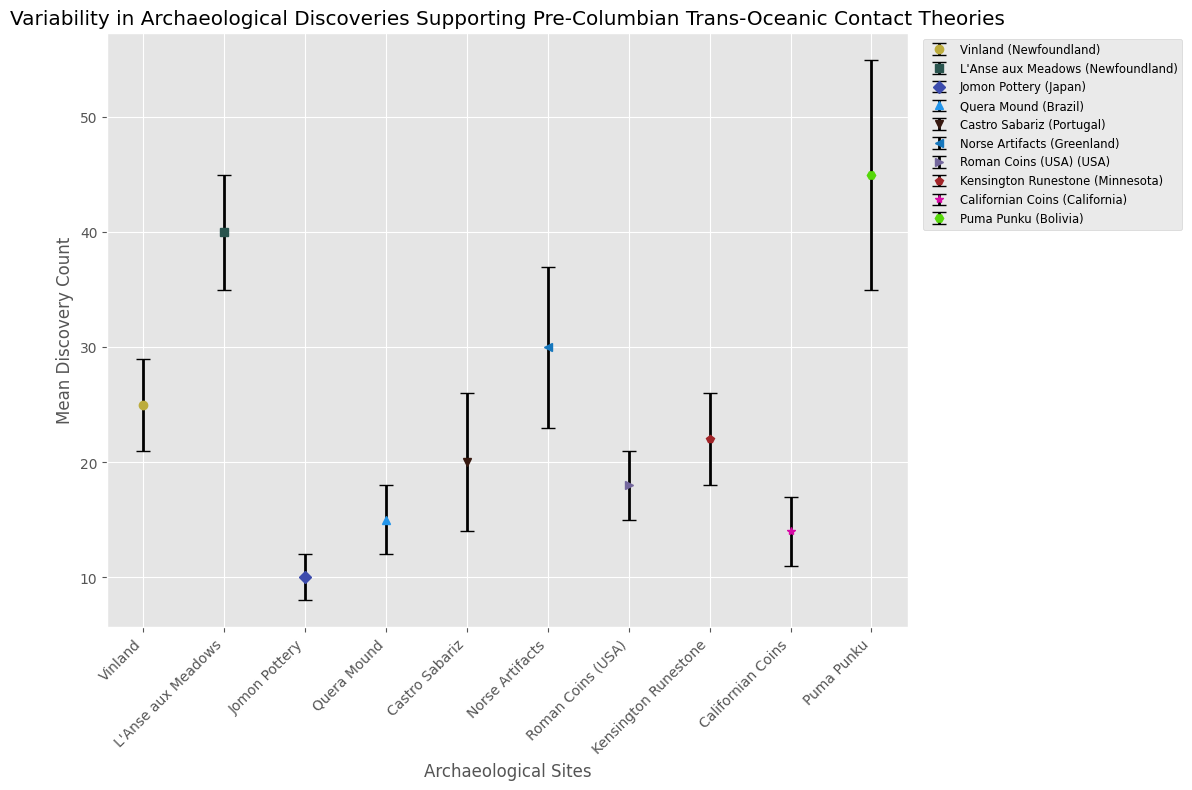Which site has the highest mean discovery count? Compare the height of the error bars for all sites. Puma Punku has the highest mean discovery count with 45.
Answer: Puma Punku Which site has the lowest mean discovery count? Compare the height of the error bars for all sites. Jomon Pottery has the lowest mean discovery count with 10.
Answer: Jomon Pottery What's the sum of mean discovery counts for Vinland and Norse Artifacts? Vinland has a mean discovery count of 25, and Norse Artifacts has 30. The sum is 25 + 30.
Answer: 55 Which site in Newfoundland has the highest mean discovery count? L'Anse aux Meadows and Vinland are both located in Newfoundland. Compare their mean discovery counts: Vinland (25) and L'Anse aux Meadows (40). L'Anse aux Meadows is higher.
Answer: L'Anse aux Meadows Which site's error bars are the longest? Look for the error bar with the largest range. Puma Punku has the longest error bars with a standard deviation of 10.
Answer: Puma Punku What's the difference in mean discovery counts between Castro Sabariz and Kensington Runestone? Castro Sabariz has a mean of 20, and Kensington Runestone has 22. The difference is 22 - 20.
Answer: 2 Which site in the USA has a higher mean discovery count, Roman Coins or Kensington Runestone? Compare Roman Coins (18) and Kensington Runestone (22). Kensington Runestone is higher.
Answer: Kensington Runestone What is the average mean discovery count of the sites located in the USA? The sites in the USA are Roman Coins (18), Kensington Runestone (22), and Californian Coins (14). The average is (18 + 22 + 14) / 3.
Answer: 18 Which site has the second highest standard deviation? Compare all standard deviations. The highest is Puma Punku (10), the second highest is Norse Artifacts (7).
Answer: Norse Artifacts What's the combined mean discovery count for the sites located in Newfoundland? Newfoundland sites are Vinland and L'Anse aux Meadows. The combined mean is 25 + 40.
Answer: 65 